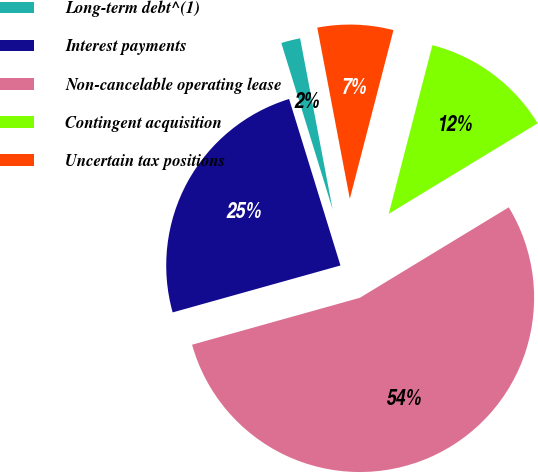<chart> <loc_0><loc_0><loc_500><loc_500><pie_chart><fcel>Long-term debt^(1)<fcel>Interest payments<fcel>Non-cancelable operating lease<fcel>Contingent acquisition<fcel>Uncertain tax positions<nl><fcel>1.77%<fcel>24.58%<fcel>54.35%<fcel>12.28%<fcel>7.02%<nl></chart> 